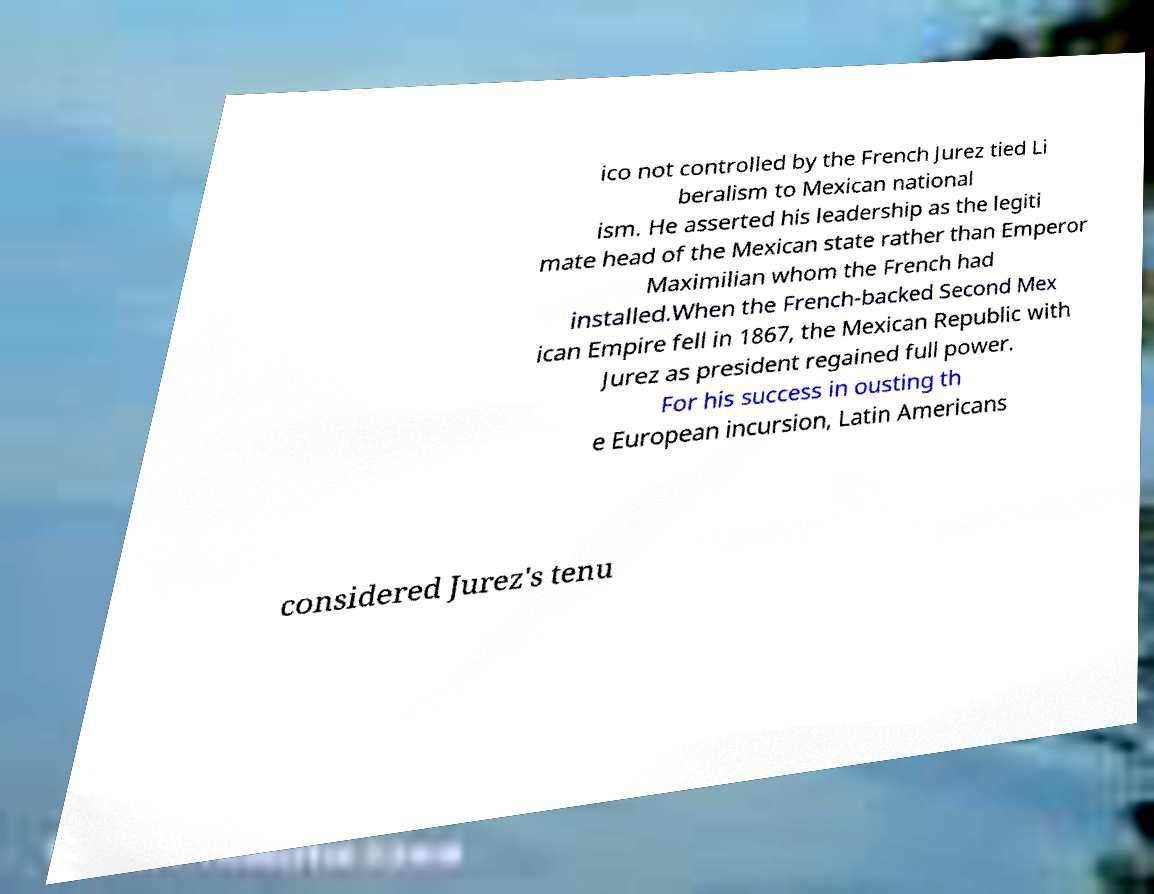Could you assist in decoding the text presented in this image and type it out clearly? ico not controlled by the French Jurez tied Li beralism to Mexican national ism. He asserted his leadership as the legiti mate head of the Mexican state rather than Emperor Maximilian whom the French had installed.When the French-backed Second Mex ican Empire fell in 1867, the Mexican Republic with Jurez as president regained full power. For his success in ousting th e European incursion, Latin Americans considered Jurez's tenu 